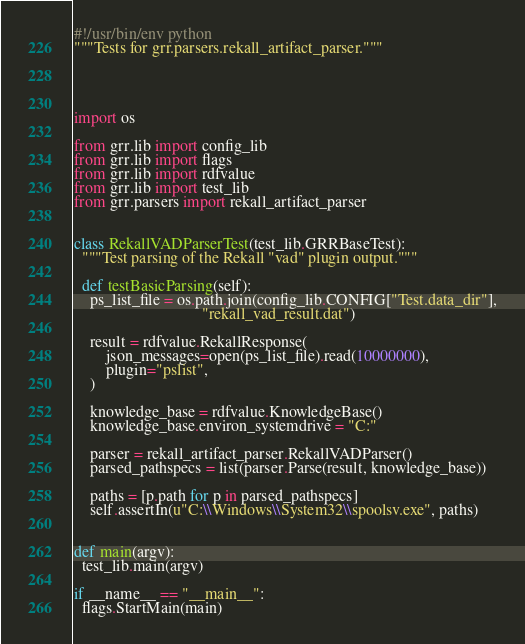Convert code to text. <code><loc_0><loc_0><loc_500><loc_500><_Python_>#!/usr/bin/env python
"""Tests for grr.parsers.rekall_artifact_parser."""




import os

from grr.lib import config_lib
from grr.lib import flags
from grr.lib import rdfvalue
from grr.lib import test_lib
from grr.parsers import rekall_artifact_parser


class RekallVADParserTest(test_lib.GRRBaseTest):
  """Test parsing of the Rekall "vad" plugin output."""

  def testBasicParsing(self):
    ps_list_file = os.path.join(config_lib.CONFIG["Test.data_dir"],
                                "rekall_vad_result.dat")

    result = rdfvalue.RekallResponse(
        json_messages=open(ps_list_file).read(10000000),
        plugin="pslist",
    )

    knowledge_base = rdfvalue.KnowledgeBase()
    knowledge_base.environ_systemdrive = "C:"

    parser = rekall_artifact_parser.RekallVADParser()
    parsed_pathspecs = list(parser.Parse(result, knowledge_base))

    paths = [p.path for p in parsed_pathspecs]
    self.assertIn(u"C:\\Windows\\System32\\spoolsv.exe", paths)


def main(argv):
  test_lib.main(argv)

if __name__ == "__main__":
  flags.StartMain(main)
</code> 